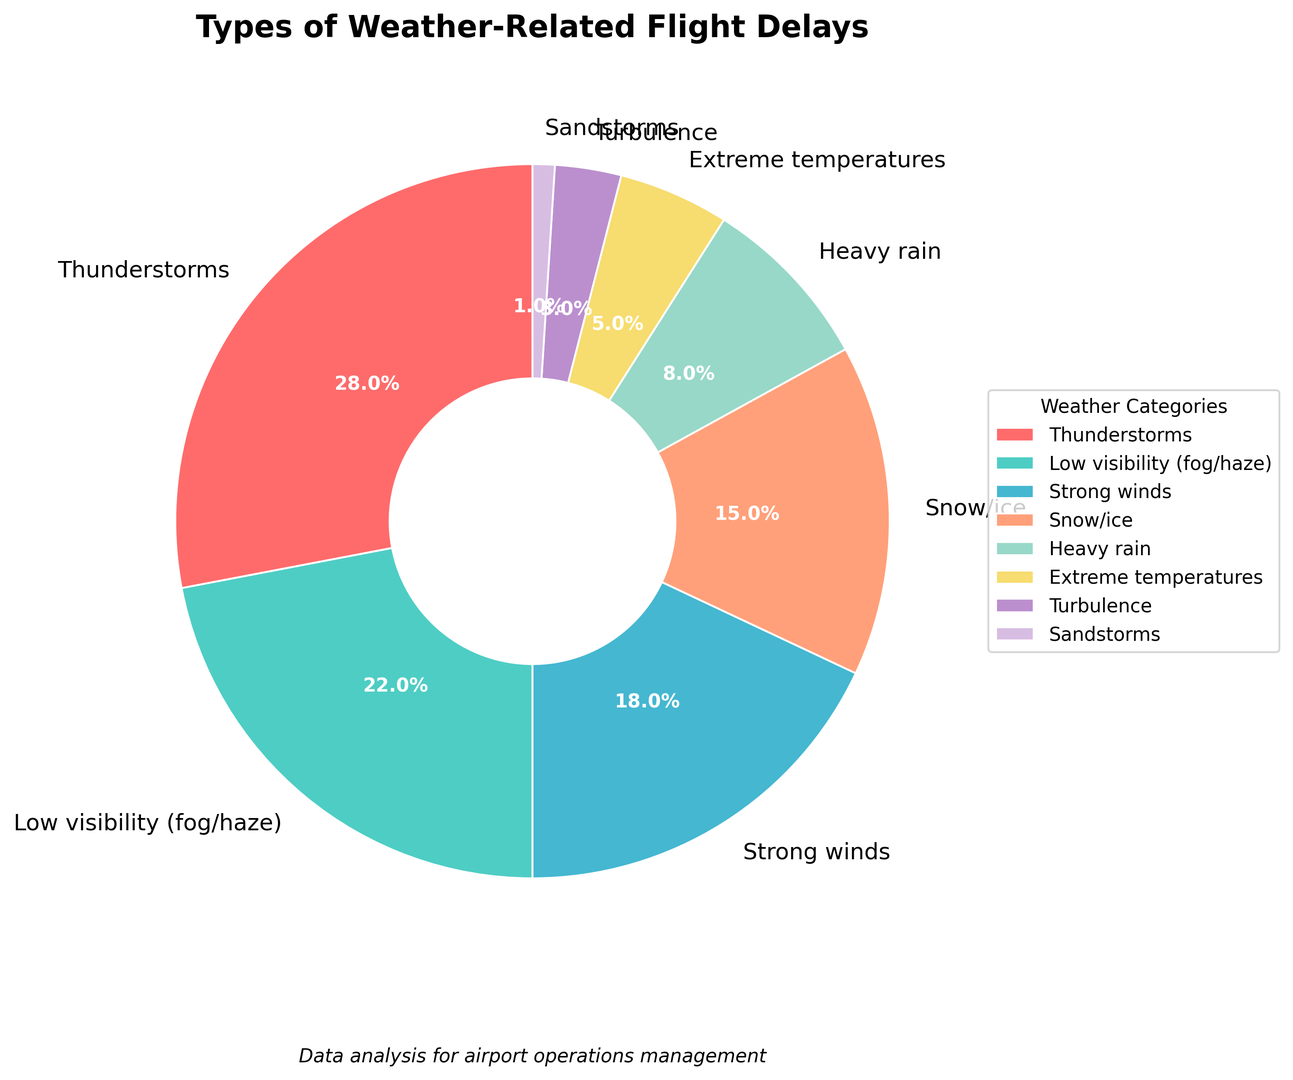What percentage of flight delays are caused by thunderstorms? The chart shows the categories of weather-related flight delays with their corresponding percentages. From the chart, we can see that the segment labelled "Thunderstorms" represents 28%. Therefore, flight delays due to thunderstorms account for 28% of the total.
Answer: 28% How do the percentages of delays due to low visibility and strong winds compare? The chart indicates that low visibility accounts for 22% of delays and strong winds account for 18%. By comparing these two values, we see that low visibility causes a higher percentage of delays than strong winds.
Answer: Low visibility causes 4% more delays than strong winds What is the total percentage of flight delays caused by snow/ice and heavy rain combined? From the chart, the percentage of delays due to snow/ice is 15% and for heavy rain is 8%. By summing these values: 15% + 8% = 23%, the combined total percentage of delays from snow/ice and heavy rain is 23%.
Answer: 23% Which category has the smallest percentage of delays and what is its percentage? The chart shows various categories of weather-related delays. The wedge representing "Sandstorms" is the smallest, indicating the smallest percentage of delays, which is 1%.
Answer: Sandstorms, 1% Among the categories "Thunderstorms", "Low visibility", and "Strong winds", which one contributes the least to flight delays? The percentages for these categories as shown in the chart are: Thunderstorms (28%), Low visibility (22%), and Strong winds (18%). Among these, strong winds contribute the least to flight delays.
Answer: Strong winds What is the difference in percentage between delays caused by extreme temperatures and turbulence? From the chart, extreme temperatures account for 5% of delays and turbulence accounts for 3%. The difference between these values is 5% - 3% = 2%.
Answer: 2% Which two categories together account for more than half of the total delays? The chart shows percentages for various categories. Adding the two highest percentages: Thunderstorms (28%) and Low visibility (22%), we get 28% + 22% = 50%. These two together account for exactly half of the total delays. To account for more than half, we would need to include at least one more category, making the two categories contributing more significant not possible.
Answer: None What visual attributes help identify the largest category of delays? The chart uses color and size to represent different categories. The largest segment, "Thunderstorms", is notably larger than others and bright red in color, making it visually distinct and easily identifiable as the largest category.
Answer: Bright red and largest segment Which weather category contributes to delays more heavily - heavy rain or snow/ice? According to the chart, heavy rain accounts for 8% of delays, while snow/ice accounts for 15%. By comparison, snow/ice contributes more heavily to delays than heavy rain.
Answer: Snow/ice How does the percentage of delays from turbulence compare to those from sandstorms? Looking at the chart, the percentage of delays due to turbulence is 3%, and those due to sandstorms is 1%. Therefore, turbulence causes a higher percentage of delays than sandstorms.
Answer: Turbulence 